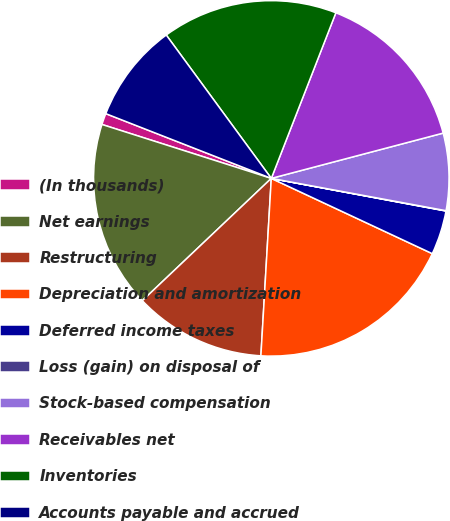<chart> <loc_0><loc_0><loc_500><loc_500><pie_chart><fcel>(In thousands)<fcel>Net earnings<fcel>Restructuring<fcel>Depreciation and amortization<fcel>Deferred income taxes<fcel>Loss (gain) on disposal of<fcel>Stock-based compensation<fcel>Receivables net<fcel>Inventories<fcel>Accounts payable and accrued<nl><fcel>1.03%<fcel>16.98%<fcel>11.99%<fcel>18.97%<fcel>4.02%<fcel>0.03%<fcel>7.01%<fcel>14.98%<fcel>15.98%<fcel>9.0%<nl></chart> 